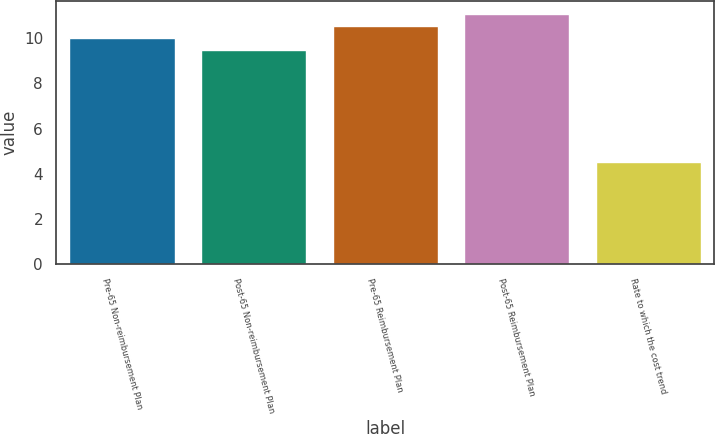<chart> <loc_0><loc_0><loc_500><loc_500><bar_chart><fcel>Pre-65 Non-reimbursement Plan<fcel>Post-65 Non-reimbursement Plan<fcel>Pre-65 Reimbursement Plan<fcel>Post-65 Reimbursement Plan<fcel>Rate to which the cost trend<nl><fcel>10.03<fcel>9.5<fcel>10.56<fcel>11.09<fcel>4.5<nl></chart> 